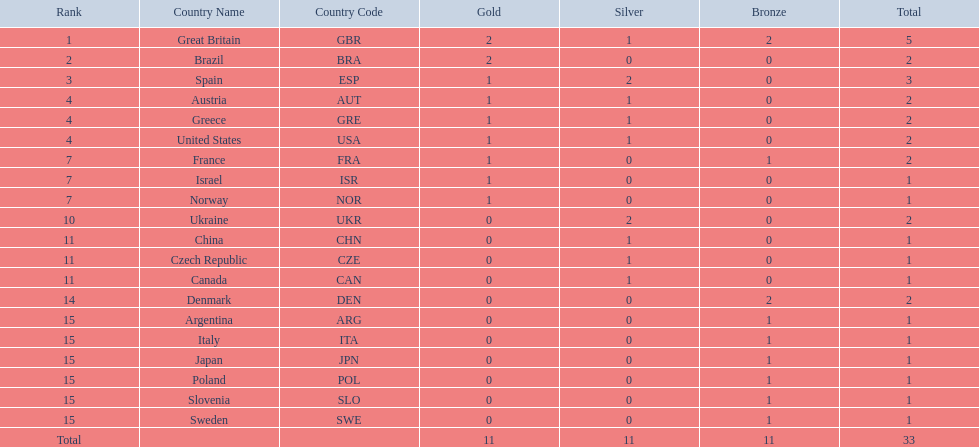How many medals did spain gain 3. Only country that got more medals? Spain (ESP). 